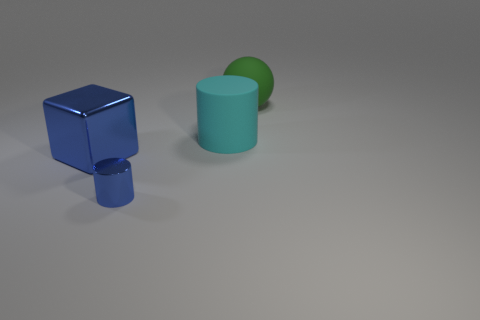Add 3 big rubber spheres. How many objects exist? 7 Subtract all blocks. How many objects are left? 3 Subtract 0 green cylinders. How many objects are left? 4 Subtract all big green objects. Subtract all blue objects. How many objects are left? 1 Add 1 big green balls. How many big green balls are left? 2 Add 4 big green rubber balls. How many big green rubber balls exist? 5 